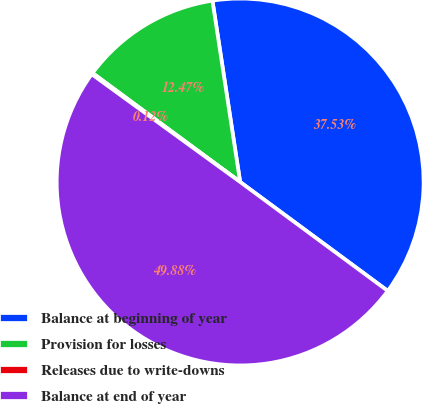Convert chart to OTSL. <chart><loc_0><loc_0><loc_500><loc_500><pie_chart><fcel>Balance at beginning of year<fcel>Provision for losses<fcel>Releases due to write-downs<fcel>Balance at end of year<nl><fcel>37.53%<fcel>12.47%<fcel>0.12%<fcel>49.88%<nl></chart> 